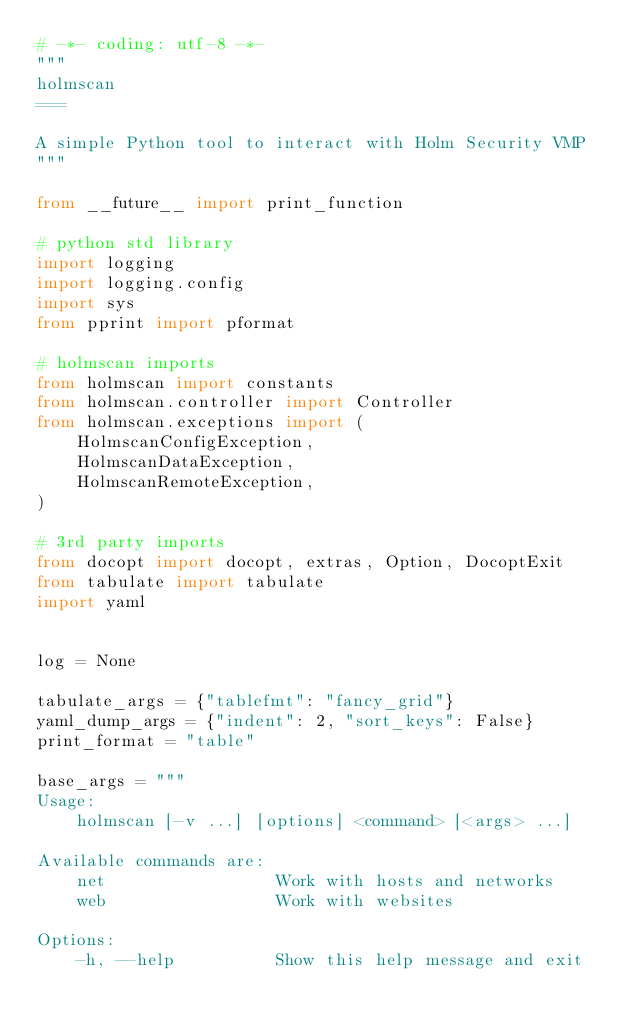<code> <loc_0><loc_0><loc_500><loc_500><_Python_># -*- coding: utf-8 -*-
"""
holmscan
===

A simple Python tool to interact with Holm Security VMP
"""

from __future__ import print_function

# python std library
import logging
import logging.config
import sys
from pprint import pformat

# holmscan imports
from holmscan import constants
from holmscan.controller import Controller
from holmscan.exceptions import (
    HolmscanConfigException,
    HolmscanDataException,
    HolmscanRemoteException,
)

# 3rd party imports
from docopt import docopt, extras, Option, DocoptExit
from tabulate import tabulate
import yaml


log = None

tabulate_args = {"tablefmt": "fancy_grid"}
yaml_dump_args = {"indent": 2, "sort_keys": False}
print_format = "table"

base_args = """
Usage:
    holmscan [-v ...] [options] <command> [<args> ...]

Available commands are:
    net                 Work with hosts and networks
    web                 Work with websites

Options:
    -h, --help          Show this help message and exit</code> 